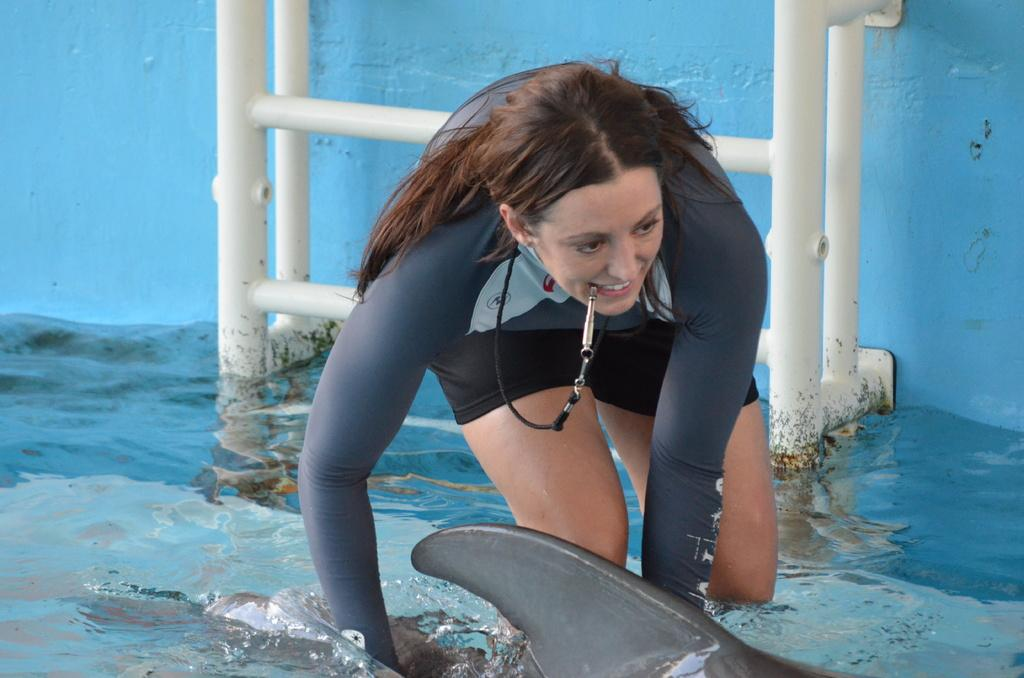Who is the main subject in the image? There is a lady in the center of the image. Where is the image taken? The image is taken in the water. What is located behind the lady? There is a ladder behind the lady. What is the lady doing in the image? The lady is trying to catch a fish. What type of loaf is the lady holding in the image? There is no loaf present in the image; the lady is trying to catch a fish. Is there a collar visible on the lady in the image? There is no collar visible on the lady in the image. 